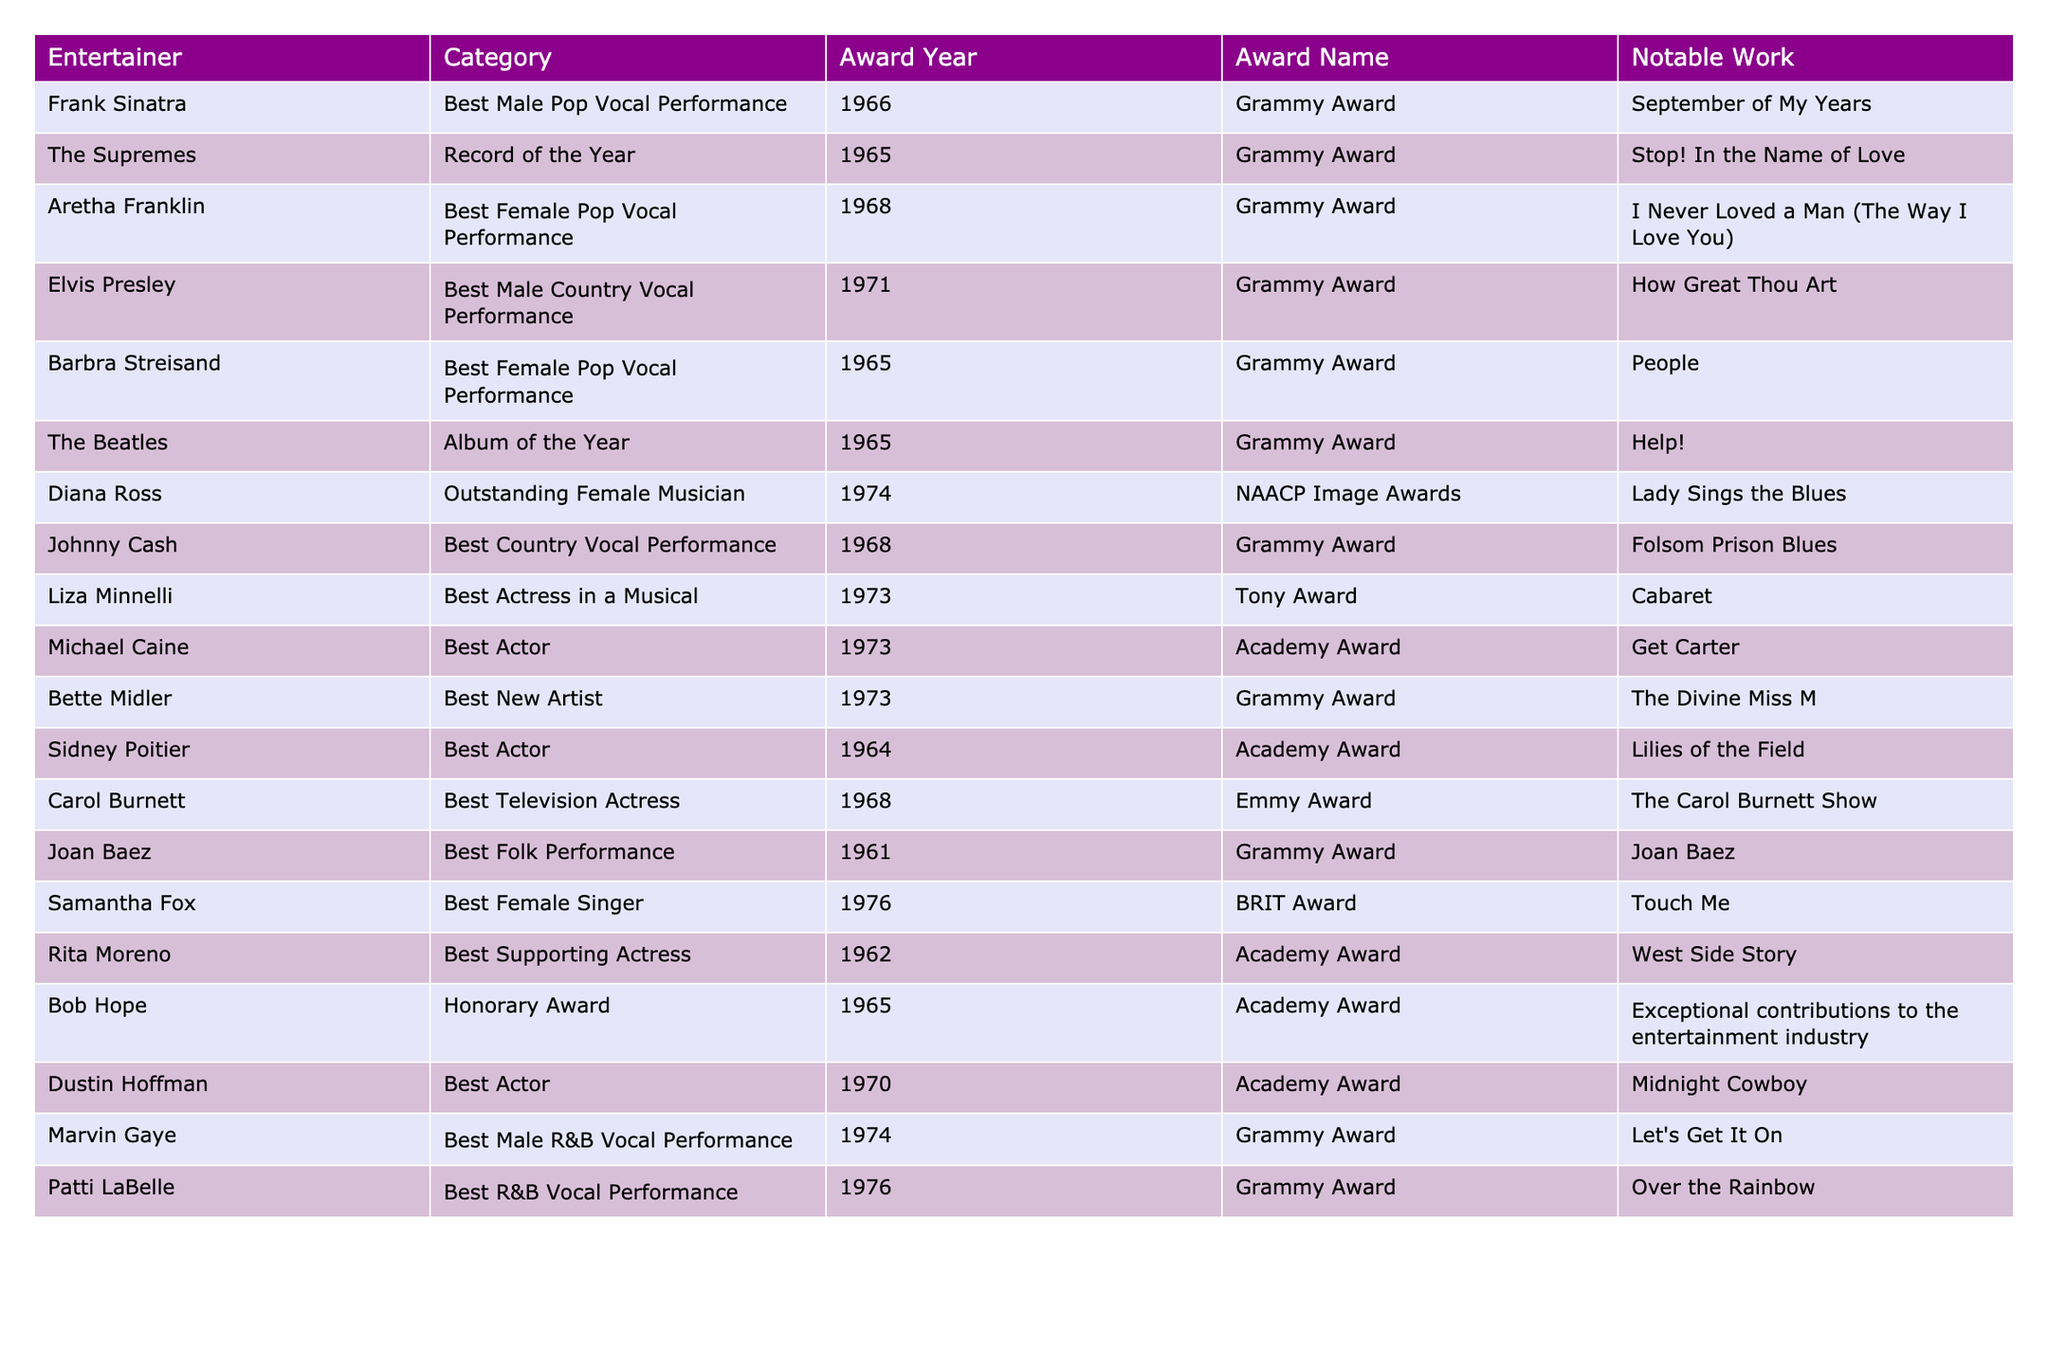What award did Aretha Franklin win in 1968? Aretha Franklin won the Grammy Award for Best Female Pop Vocal Performance in 1968.
Answer: Best Female Pop Vocal Performance How many entertainers received Grammy Awards in the 1960s? A total of six entertainers received Grammy Awards in the 1960s as listed: The Supremes, Barbra Streisand, Joan Baez, Frank Sinatra, Aretha Franklin, and Johnny Cash.
Answer: 6 Which entertainer won an Oscar in 1964? Sidney Poitier won an Academy Award (Oscar) in 1964 for his role in "Lilies of the Field."
Answer: Sidney Poitier Did Carol Burnett win an Emmy Award for "The Carol Burnett Show"? Yes, Carol Burnett won the Emmy Award for Best Television Actress for "The Carol Burnett Show" in 1968.
Answer: Yes Who received the Grammy Award for Best New Artist in 1973? Bette Midler received the Grammy Award for Best New Artist in 1973.
Answer: Bette Midler What notable work did Elvis Presley perform to win a Grammy Award in 1971? Elvis Presley won the Grammy Award for Best Male Country Vocal Performance in 1971 for his notable work "How Great Thou Art."
Answer: How Great Thou Art What is the difference in years between the Grammy Awards received by The Supremes and Johnny Cash? The Supremes won their Grammy Award in 1965, while Johnny Cash received his in 1968, making the difference 3 years.
Answer: 3 years Which two categories had entertainers winning awards in 1973? The two categories with awards in 1973 were Best Actress in a Musical (Liza Minnelli) and Best New Artist (Bette Midler).
Answer: 2 categories Who received the last award listed in the table and what type was it? The last award listed was received by Patti LaBelle in 1976, which was a Grammy Award for Best R&B Vocal Performance.
Answer: Grammy Award True or False: Michael Caine won a Grammy Award. False, Michael Caine won an Academy Award, not a Grammy Award.
Answer: False Which entertainer's award was honorary and in what year? Bob Hope received an Honorary Award in 1965 for his exceptional contributions to the entertainment industry.
Answer: 1965 What was the most recent Grammy Award year represented in the table? The most recent Grammy Award year represented in the table is 1976 with Patti LaBelle's award.
Answer: 1976 